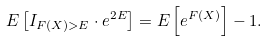Convert formula to latex. <formula><loc_0><loc_0><loc_500><loc_500>E \left [ I _ { F ( X ) > E } \cdot e ^ { 2 E } \right ] = E \left [ e ^ { F ( X ) } \right ] - 1 .</formula> 